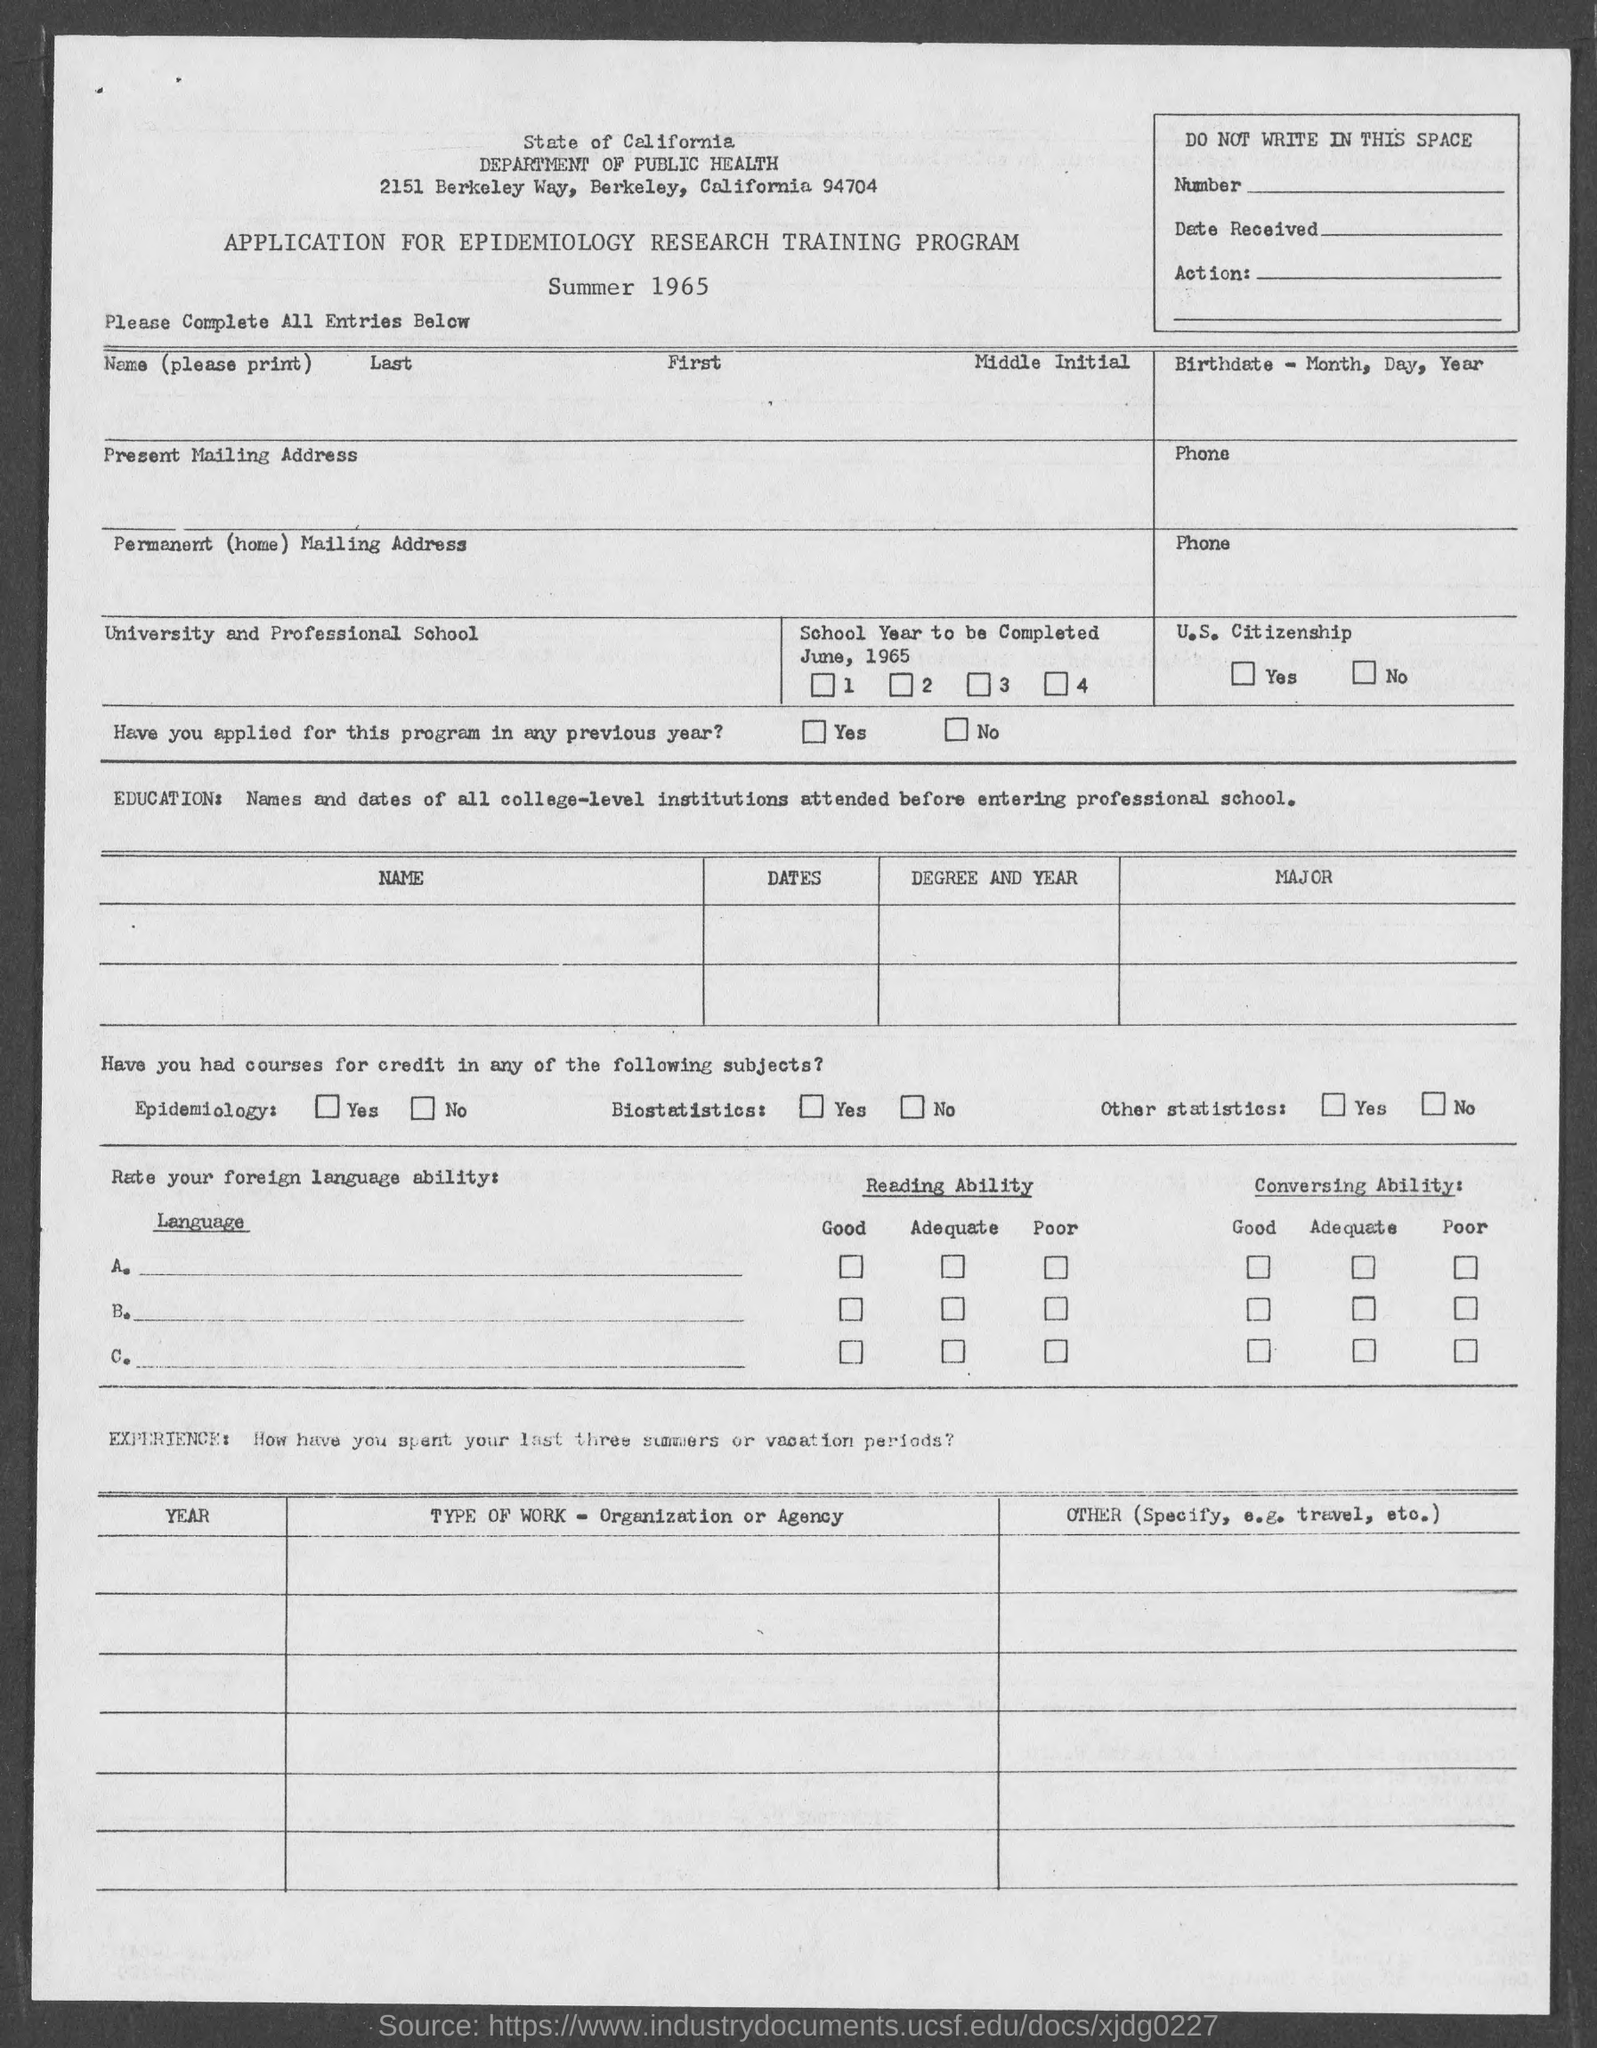In which city is state of california department of public health it ?
Provide a succinct answer. Berkeley. 